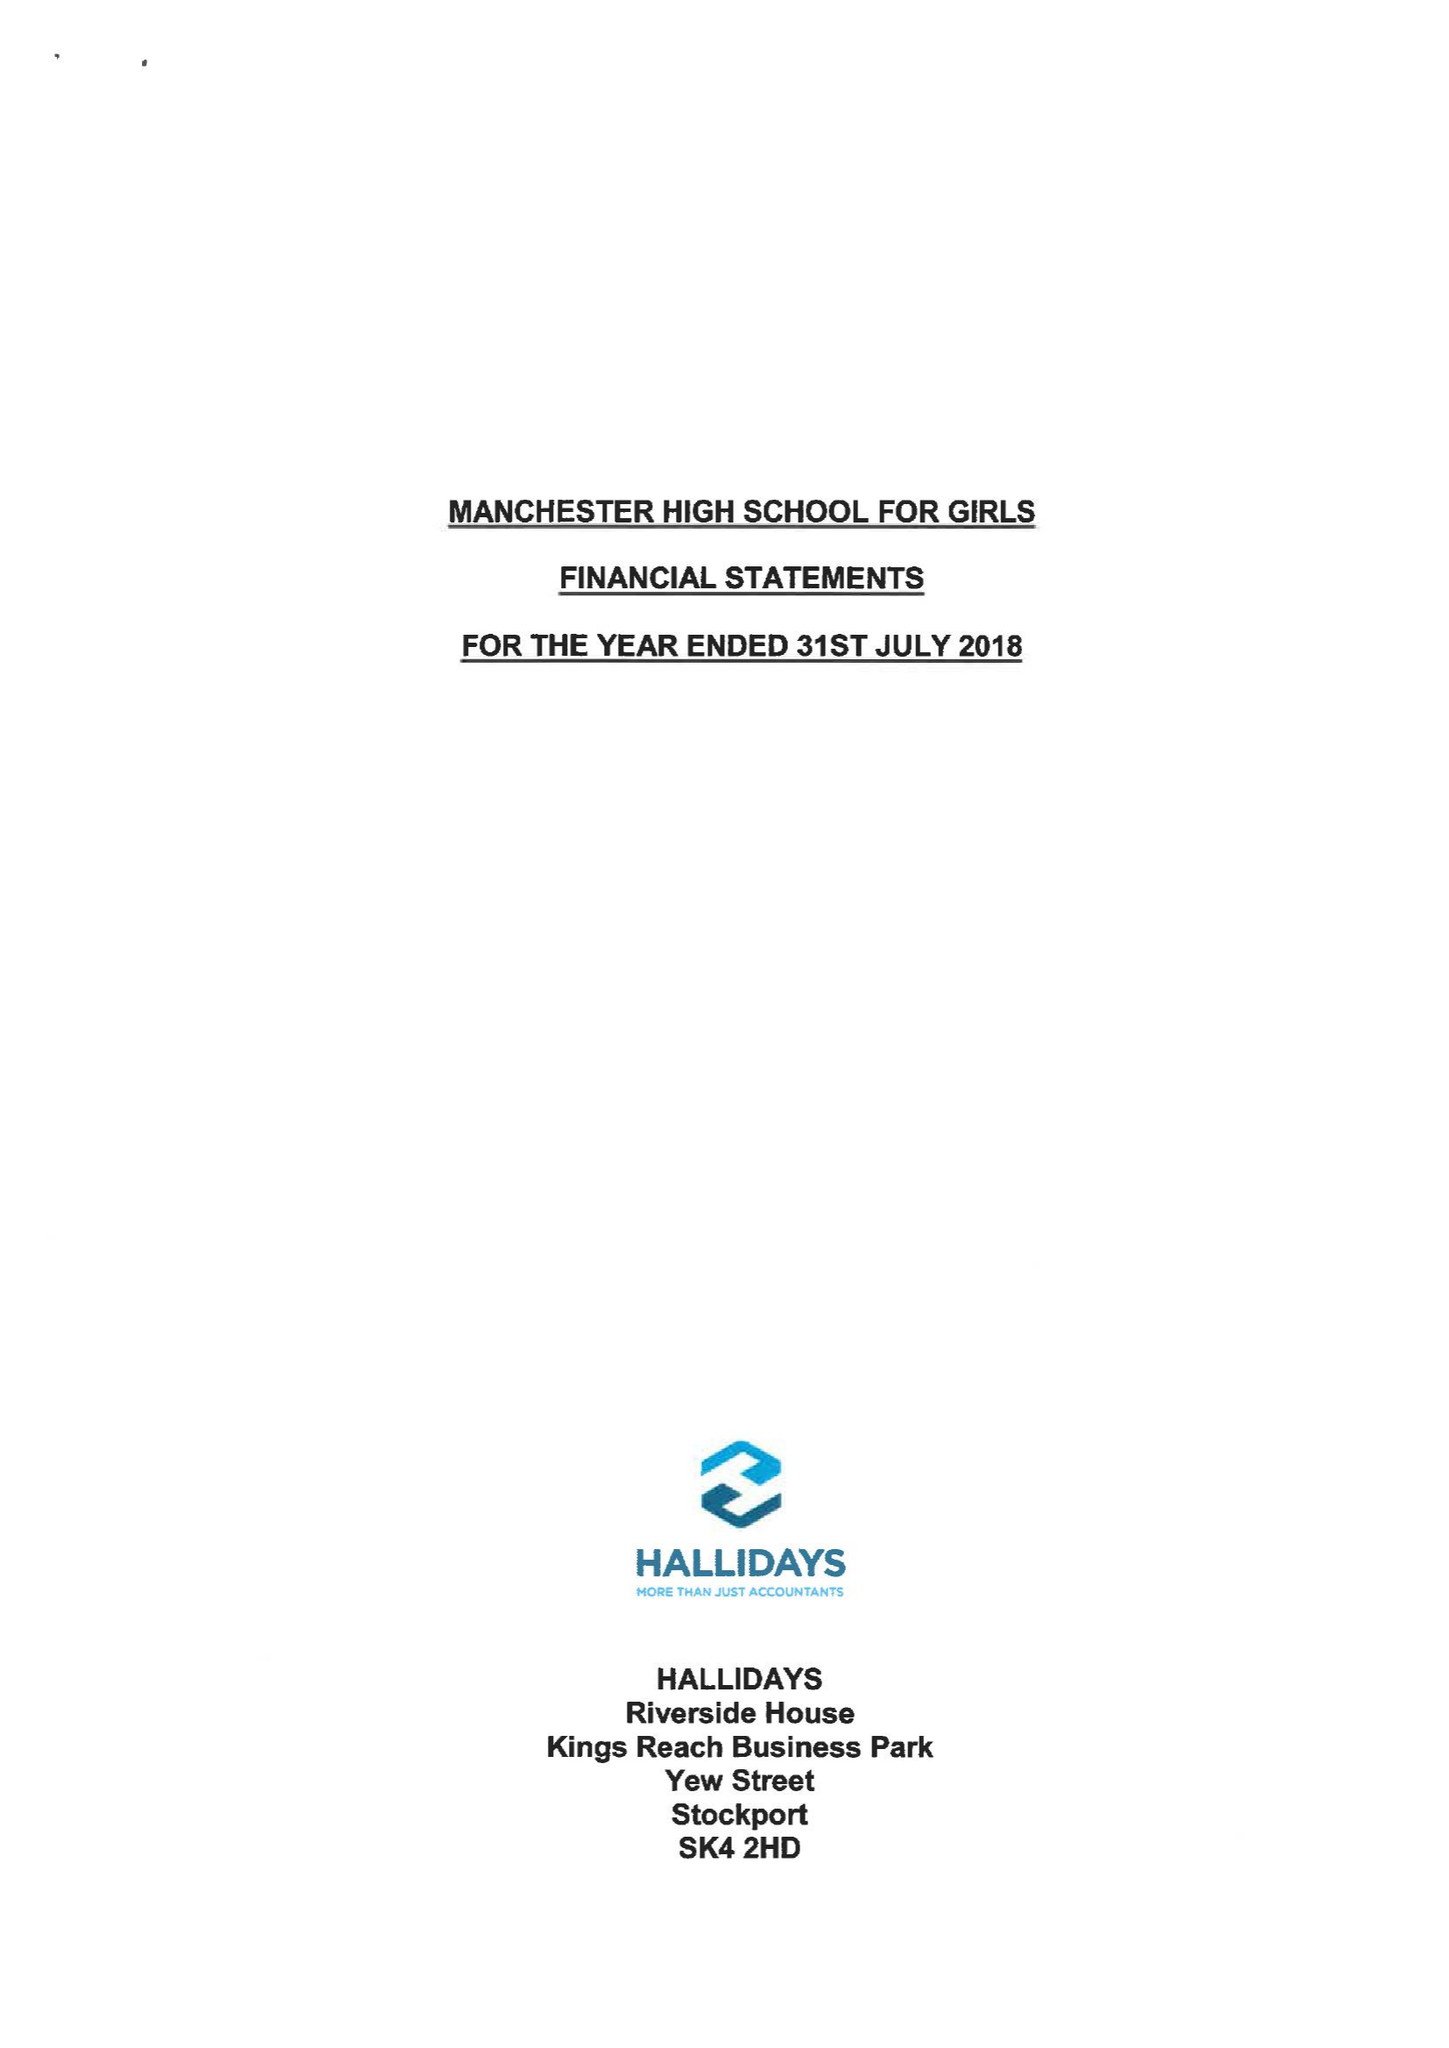What is the value for the address__post_town?
Answer the question using a single word or phrase. MANCHESTER 